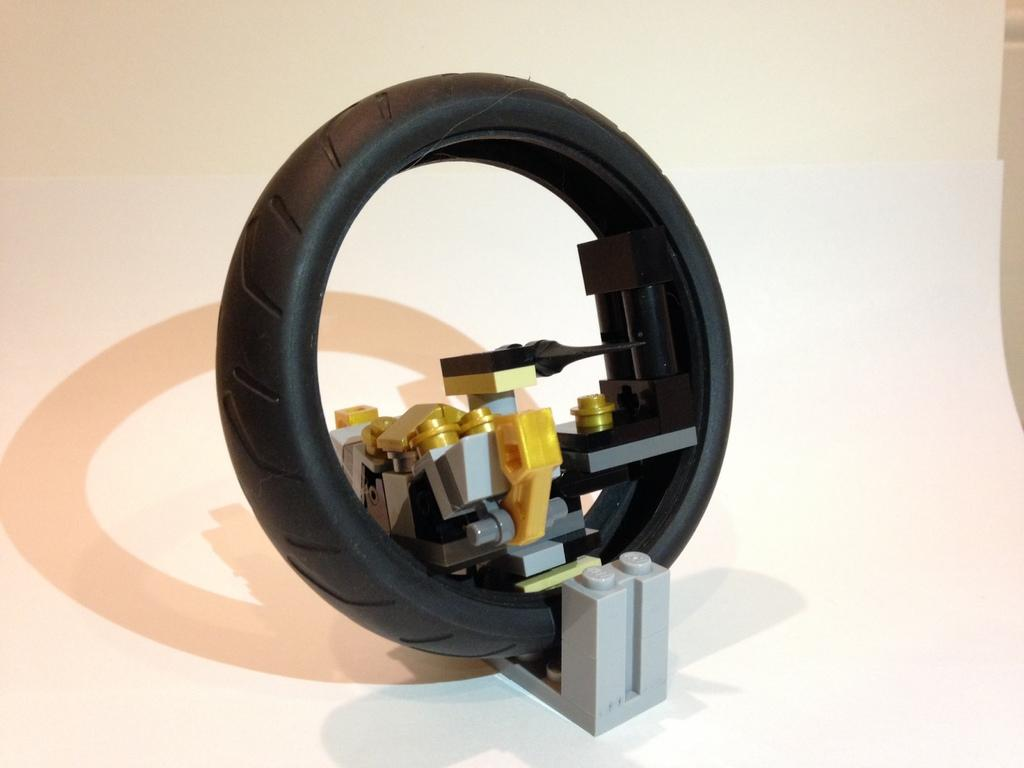What type of toy is present in the image? There is a toy in the image that resembles a tire. Can you describe the appearance of the toy? The toy resembles a tire. Where is the playground located in the image? There is no playground present in the image. What type of sponge can be seen in the image? There is no sponge present in the image. Can you see a donkey in the image? There is no donkey present in the image. 